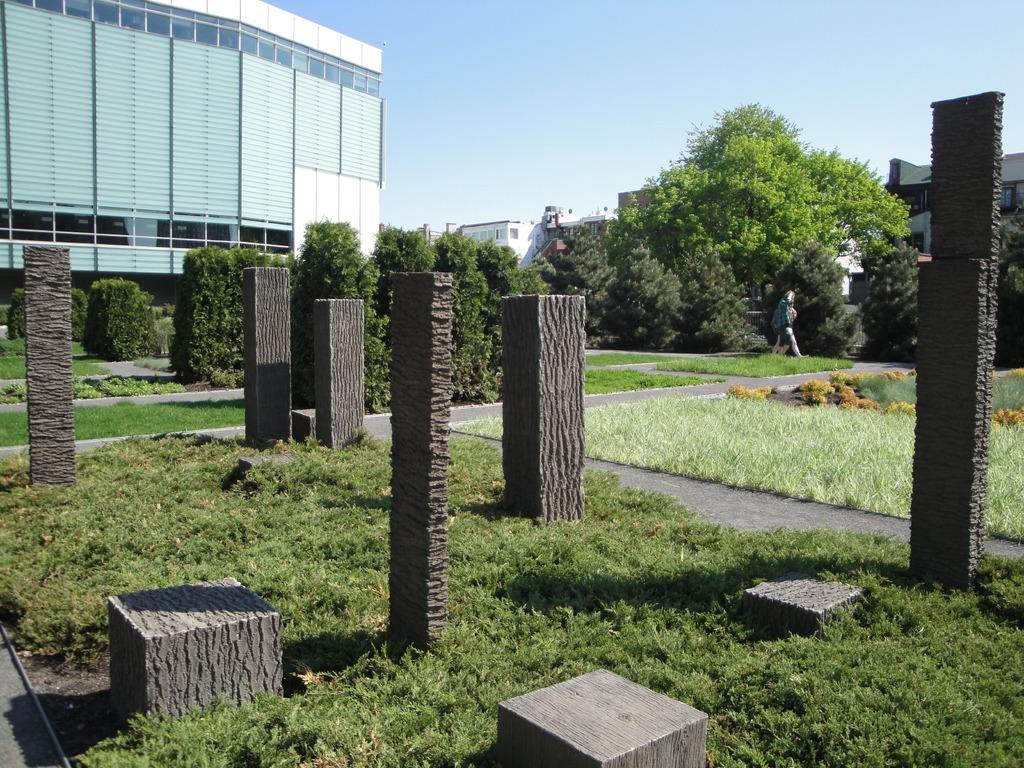What type of natural elements can be seen in the image? There are stones and green grass in the image. What is located on the right side of the image? There are trees on the right side of the image. What type of path is present in the image? There is a walkway in the image. What type of structures are visible in the image? There are buildings in the image. What can be seen in the sky in the image? Clouds are visible in the sky. How does the crowd increase in the image? There is no crowd present in the image, so it cannot increase. 